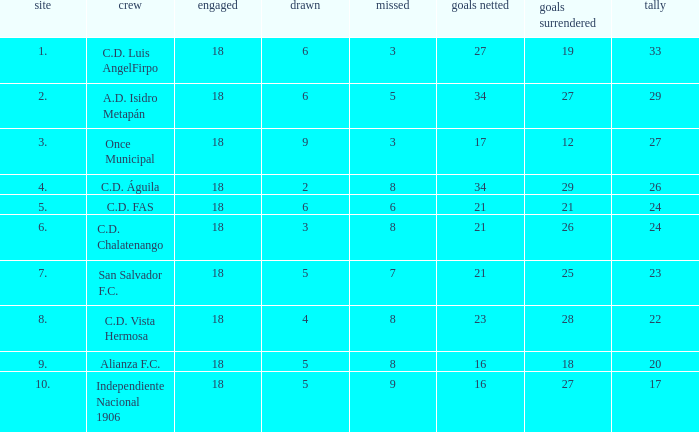What were the goal conceded that had a lost greater than 8 and more than 17 points? None. 